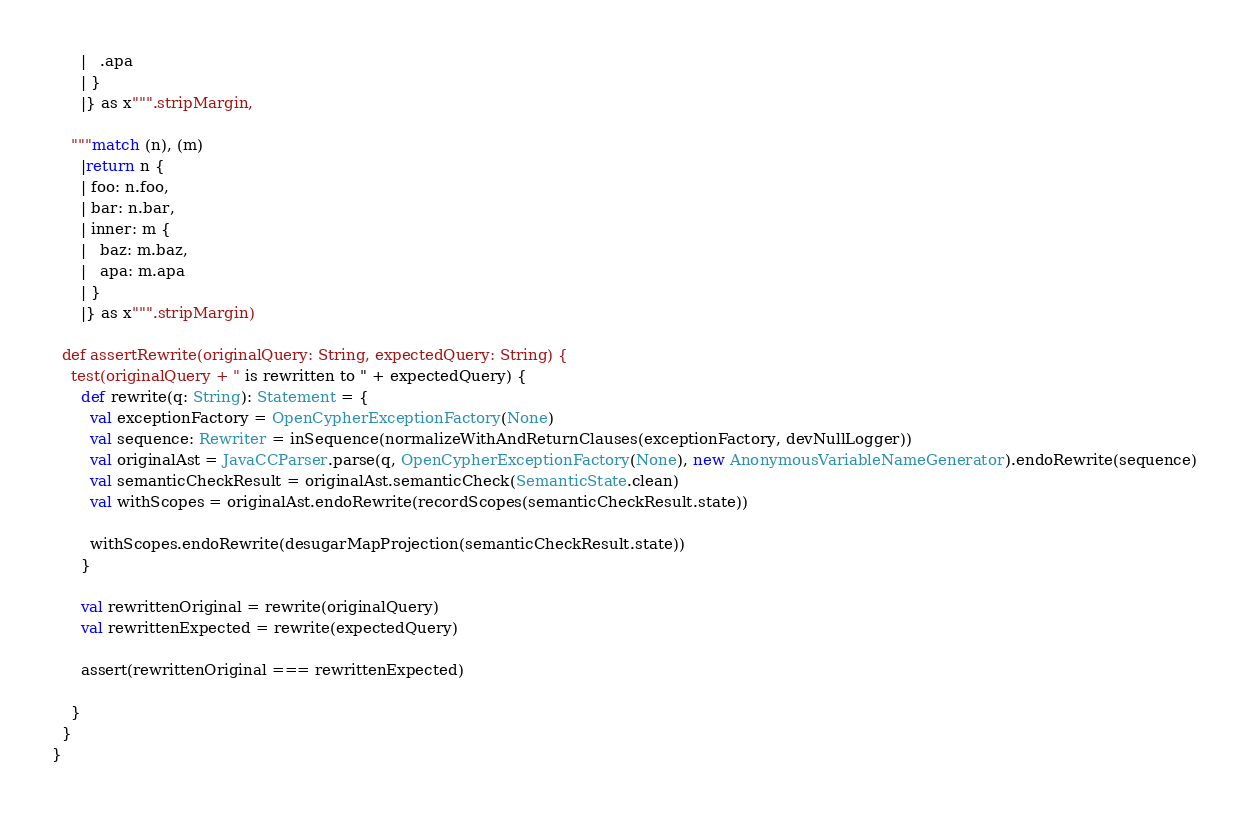Convert code to text. <code><loc_0><loc_0><loc_500><loc_500><_Scala_>      |   .apa
      | }
      |} as x""".stripMargin,

    """match (n), (m)
      |return n {
      | foo: n.foo,
      | bar: n.bar,
      | inner: m {
      |   baz: m.baz,
      |   apa: m.apa
      | }
      |} as x""".stripMargin)

  def assertRewrite(originalQuery: String, expectedQuery: String) {
    test(originalQuery + " is rewritten to " + expectedQuery) {
      def rewrite(q: String): Statement = {
        val exceptionFactory = OpenCypherExceptionFactory(None)
        val sequence: Rewriter = inSequence(normalizeWithAndReturnClauses(exceptionFactory, devNullLogger))
        val originalAst = JavaCCParser.parse(q, OpenCypherExceptionFactory(None), new AnonymousVariableNameGenerator).endoRewrite(sequence)
        val semanticCheckResult = originalAst.semanticCheck(SemanticState.clean)
        val withScopes = originalAst.endoRewrite(recordScopes(semanticCheckResult.state))

        withScopes.endoRewrite(desugarMapProjection(semanticCheckResult.state))
      }

      val rewrittenOriginal = rewrite(originalQuery)
      val rewrittenExpected = rewrite(expectedQuery)

      assert(rewrittenOriginal === rewrittenExpected)

    }
  }
}
</code> 